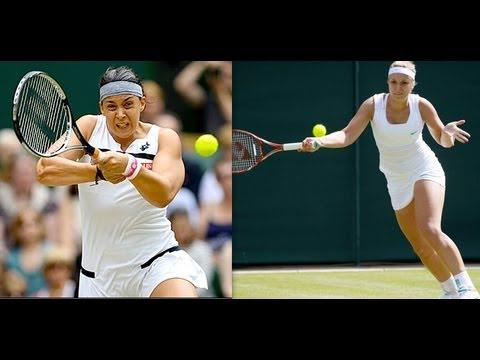Does she have an audience watching her?
Give a very brief answer. Yes. Are both pictures the same?
Short answer required. No. How many people are shown?
Write a very short answer. 2. What is this sport?
Give a very brief answer. Tennis. Are these two images the same?
Be succinct. No. 